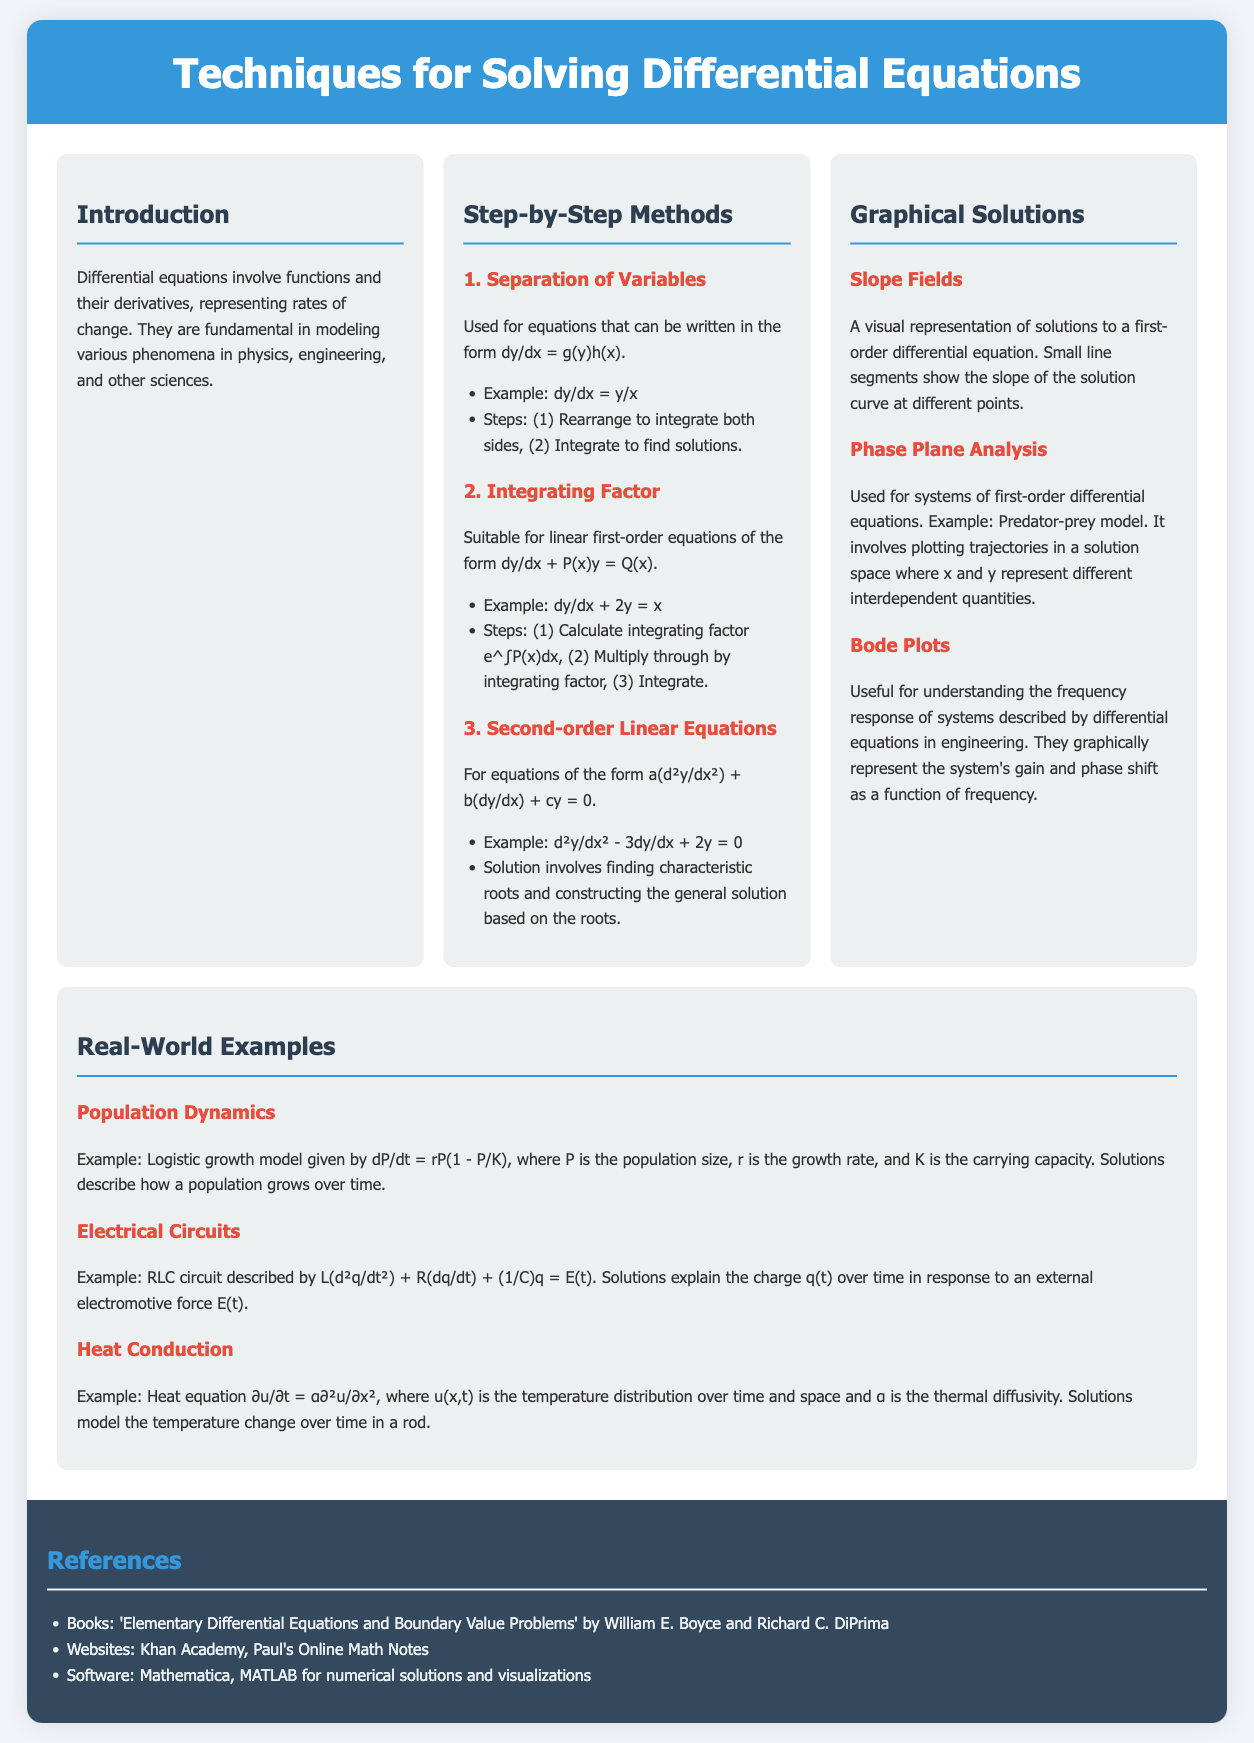What is the title of the document? The title is explicitly stated in the header section of the document.
Answer: Techniques for Solving Differential Equations What are the three methods listed under Step-by-Step Methods? The document lists key techniques for solving differential equations in the "Step-by-Step Methods" section.
Answer: Separation of Variables, Integrating Factor, Second-order Linear Equations What is the example provided for the Integrating Factor method? The example is given below the explanation for the Integrating Factor method in the document.
Answer: dy/dx + 2y = x What does the heat equation represent in real-world applications? The heat equation is described in the context of temperature distribution over time and space in the document.
Answer: Temperature change in a rod Which method is suitable for systems of first-order differential equations? The document specifically mentions the method used for analyzing such systems in the "Graphical Solutions" section.
Answer: Phase Plane Analysis What is the main focus of the Introduction section? The Introduction outlines the general concept and significance of differential equations in various fields.
Answer: Rates of change How can Bode Plots be used? The use of Bode Plots is explained in the context of their applicability in engineering.
Answer: Frequency response of systems What is the reference book listed in the document? The document mentions a specific book as part of its references for further reading.
Answer: Elementary Differential Equations and Boundary Value Problems 